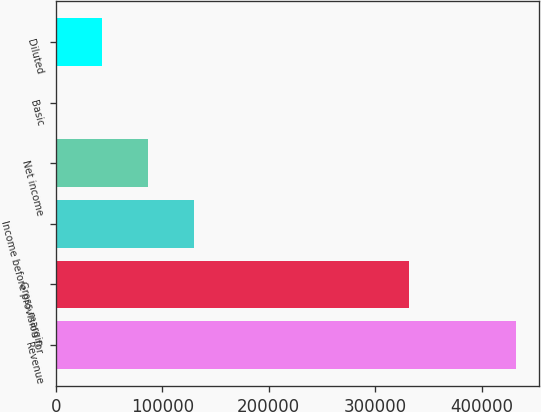Convert chart to OTSL. <chart><loc_0><loc_0><loc_500><loc_500><bar_chart><fcel>Revenue<fcel>Gross margin<fcel>Income before provision for<fcel>Net income<fcel>Basic<fcel>Diluted<nl><fcel>432561<fcel>332055<fcel>129768<fcel>86512.3<fcel>0.14<fcel>43256.2<nl></chart> 